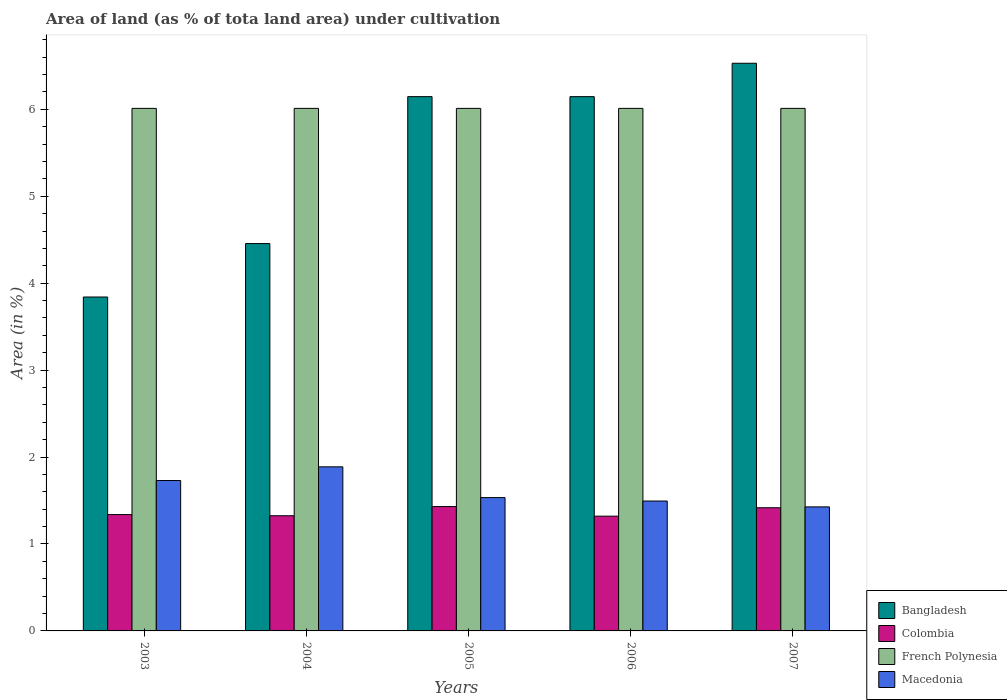How many different coloured bars are there?
Your answer should be compact. 4. How many groups of bars are there?
Offer a terse response. 5. Are the number of bars on each tick of the X-axis equal?
Make the answer very short. Yes. How many bars are there on the 1st tick from the left?
Make the answer very short. 4. How many bars are there on the 5th tick from the right?
Ensure brevity in your answer.  4. What is the label of the 1st group of bars from the left?
Make the answer very short. 2003. In how many cases, is the number of bars for a given year not equal to the number of legend labels?
Provide a succinct answer. 0. What is the percentage of land under cultivation in Bangladesh in 2005?
Your answer should be very brief. 6.15. Across all years, what is the maximum percentage of land under cultivation in Bangladesh?
Offer a terse response. 6.53. Across all years, what is the minimum percentage of land under cultivation in Colombia?
Keep it short and to the point. 1.32. What is the total percentage of land under cultivation in French Polynesia in the graph?
Provide a short and direct response. 30.05. What is the difference between the percentage of land under cultivation in Colombia in 2003 and the percentage of land under cultivation in Macedonia in 2005?
Offer a very short reply. -0.2. What is the average percentage of land under cultivation in Colombia per year?
Provide a succinct answer. 1.37. In the year 2005, what is the difference between the percentage of land under cultivation in French Polynesia and percentage of land under cultivation in Colombia?
Your answer should be compact. 4.58. What is the ratio of the percentage of land under cultivation in Bangladesh in 2005 to that in 2006?
Offer a very short reply. 1. What is the difference between the highest and the lowest percentage of land under cultivation in Bangladesh?
Offer a very short reply. 2.69. In how many years, is the percentage of land under cultivation in Macedonia greater than the average percentage of land under cultivation in Macedonia taken over all years?
Offer a very short reply. 2. What does the 4th bar from the left in 2006 represents?
Ensure brevity in your answer.  Macedonia. What does the 1st bar from the right in 2005 represents?
Provide a short and direct response. Macedonia. Is it the case that in every year, the sum of the percentage of land under cultivation in Bangladesh and percentage of land under cultivation in Colombia is greater than the percentage of land under cultivation in Macedonia?
Ensure brevity in your answer.  Yes. How many bars are there?
Ensure brevity in your answer.  20. How many years are there in the graph?
Your answer should be very brief. 5. Are the values on the major ticks of Y-axis written in scientific E-notation?
Ensure brevity in your answer.  No. Does the graph contain grids?
Provide a short and direct response. No. What is the title of the graph?
Offer a very short reply. Area of land (as % of tota land area) under cultivation. What is the label or title of the Y-axis?
Your answer should be very brief. Area (in %). What is the Area (in %) of Bangladesh in 2003?
Give a very brief answer. 3.84. What is the Area (in %) of Colombia in 2003?
Provide a short and direct response. 1.34. What is the Area (in %) in French Polynesia in 2003?
Keep it short and to the point. 6.01. What is the Area (in %) in Macedonia in 2003?
Give a very brief answer. 1.73. What is the Area (in %) of Bangladesh in 2004?
Your answer should be very brief. 4.46. What is the Area (in %) in Colombia in 2004?
Your answer should be compact. 1.32. What is the Area (in %) of French Polynesia in 2004?
Provide a short and direct response. 6.01. What is the Area (in %) in Macedonia in 2004?
Offer a terse response. 1.89. What is the Area (in %) in Bangladesh in 2005?
Give a very brief answer. 6.15. What is the Area (in %) of Colombia in 2005?
Your response must be concise. 1.43. What is the Area (in %) in French Polynesia in 2005?
Make the answer very short. 6.01. What is the Area (in %) of Macedonia in 2005?
Ensure brevity in your answer.  1.53. What is the Area (in %) in Bangladesh in 2006?
Your response must be concise. 6.15. What is the Area (in %) in Colombia in 2006?
Provide a succinct answer. 1.32. What is the Area (in %) of French Polynesia in 2006?
Provide a succinct answer. 6.01. What is the Area (in %) in Macedonia in 2006?
Your answer should be very brief. 1.49. What is the Area (in %) of Bangladesh in 2007?
Your answer should be compact. 6.53. What is the Area (in %) of Colombia in 2007?
Keep it short and to the point. 1.42. What is the Area (in %) in French Polynesia in 2007?
Offer a terse response. 6.01. What is the Area (in %) of Macedonia in 2007?
Your answer should be compact. 1.43. Across all years, what is the maximum Area (in %) in Bangladesh?
Offer a terse response. 6.53. Across all years, what is the maximum Area (in %) in Colombia?
Provide a short and direct response. 1.43. Across all years, what is the maximum Area (in %) in French Polynesia?
Offer a very short reply. 6.01. Across all years, what is the maximum Area (in %) of Macedonia?
Make the answer very short. 1.89. Across all years, what is the minimum Area (in %) of Bangladesh?
Offer a terse response. 3.84. Across all years, what is the minimum Area (in %) in Colombia?
Ensure brevity in your answer.  1.32. Across all years, what is the minimum Area (in %) of French Polynesia?
Your response must be concise. 6.01. Across all years, what is the minimum Area (in %) in Macedonia?
Offer a terse response. 1.43. What is the total Area (in %) in Bangladesh in the graph?
Give a very brief answer. 27.12. What is the total Area (in %) of Colombia in the graph?
Ensure brevity in your answer.  6.83. What is the total Area (in %) in French Polynesia in the graph?
Provide a short and direct response. 30.05. What is the total Area (in %) of Macedonia in the graph?
Provide a short and direct response. 8.07. What is the difference between the Area (in %) of Bangladesh in 2003 and that in 2004?
Provide a short and direct response. -0.61. What is the difference between the Area (in %) of Colombia in 2003 and that in 2004?
Make the answer very short. 0.01. What is the difference between the Area (in %) of Macedonia in 2003 and that in 2004?
Your response must be concise. -0.16. What is the difference between the Area (in %) of Bangladesh in 2003 and that in 2005?
Keep it short and to the point. -2.3. What is the difference between the Area (in %) of Colombia in 2003 and that in 2005?
Keep it short and to the point. -0.09. What is the difference between the Area (in %) in Macedonia in 2003 and that in 2005?
Give a very brief answer. 0.2. What is the difference between the Area (in %) of Bangladesh in 2003 and that in 2006?
Provide a succinct answer. -2.3. What is the difference between the Area (in %) of Colombia in 2003 and that in 2006?
Offer a very short reply. 0.02. What is the difference between the Area (in %) of French Polynesia in 2003 and that in 2006?
Provide a succinct answer. 0. What is the difference between the Area (in %) of Macedonia in 2003 and that in 2006?
Provide a short and direct response. 0.24. What is the difference between the Area (in %) in Bangladesh in 2003 and that in 2007?
Offer a very short reply. -2.69. What is the difference between the Area (in %) of Colombia in 2003 and that in 2007?
Make the answer very short. -0.08. What is the difference between the Area (in %) in Macedonia in 2003 and that in 2007?
Give a very brief answer. 0.3. What is the difference between the Area (in %) in Bangladesh in 2004 and that in 2005?
Give a very brief answer. -1.69. What is the difference between the Area (in %) of Colombia in 2004 and that in 2005?
Offer a very short reply. -0.11. What is the difference between the Area (in %) of Macedonia in 2004 and that in 2005?
Your response must be concise. 0.35. What is the difference between the Area (in %) in Bangladesh in 2004 and that in 2006?
Provide a short and direct response. -1.69. What is the difference between the Area (in %) of Colombia in 2004 and that in 2006?
Offer a very short reply. 0. What is the difference between the Area (in %) in Macedonia in 2004 and that in 2006?
Your answer should be compact. 0.39. What is the difference between the Area (in %) in Bangladesh in 2004 and that in 2007?
Your answer should be compact. -2.07. What is the difference between the Area (in %) of Colombia in 2004 and that in 2007?
Make the answer very short. -0.09. What is the difference between the Area (in %) in Macedonia in 2004 and that in 2007?
Offer a very short reply. 0.46. What is the difference between the Area (in %) in Colombia in 2005 and that in 2006?
Make the answer very short. 0.11. What is the difference between the Area (in %) in Macedonia in 2005 and that in 2006?
Offer a very short reply. 0.04. What is the difference between the Area (in %) of Bangladesh in 2005 and that in 2007?
Make the answer very short. -0.38. What is the difference between the Area (in %) of Colombia in 2005 and that in 2007?
Your answer should be compact. 0.01. What is the difference between the Area (in %) of French Polynesia in 2005 and that in 2007?
Offer a very short reply. 0. What is the difference between the Area (in %) of Macedonia in 2005 and that in 2007?
Provide a succinct answer. 0.11. What is the difference between the Area (in %) in Bangladesh in 2006 and that in 2007?
Provide a short and direct response. -0.38. What is the difference between the Area (in %) in Colombia in 2006 and that in 2007?
Offer a very short reply. -0.1. What is the difference between the Area (in %) of French Polynesia in 2006 and that in 2007?
Keep it short and to the point. 0. What is the difference between the Area (in %) of Macedonia in 2006 and that in 2007?
Your answer should be compact. 0.07. What is the difference between the Area (in %) in Bangladesh in 2003 and the Area (in %) in Colombia in 2004?
Offer a very short reply. 2.52. What is the difference between the Area (in %) in Bangladesh in 2003 and the Area (in %) in French Polynesia in 2004?
Ensure brevity in your answer.  -2.17. What is the difference between the Area (in %) of Bangladesh in 2003 and the Area (in %) of Macedonia in 2004?
Your answer should be very brief. 1.95. What is the difference between the Area (in %) in Colombia in 2003 and the Area (in %) in French Polynesia in 2004?
Offer a very short reply. -4.67. What is the difference between the Area (in %) of Colombia in 2003 and the Area (in %) of Macedonia in 2004?
Your response must be concise. -0.55. What is the difference between the Area (in %) of French Polynesia in 2003 and the Area (in %) of Macedonia in 2004?
Your answer should be compact. 4.12. What is the difference between the Area (in %) in Bangladesh in 2003 and the Area (in %) in Colombia in 2005?
Make the answer very short. 2.41. What is the difference between the Area (in %) in Bangladesh in 2003 and the Area (in %) in French Polynesia in 2005?
Provide a short and direct response. -2.17. What is the difference between the Area (in %) of Bangladesh in 2003 and the Area (in %) of Macedonia in 2005?
Give a very brief answer. 2.31. What is the difference between the Area (in %) of Colombia in 2003 and the Area (in %) of French Polynesia in 2005?
Provide a short and direct response. -4.67. What is the difference between the Area (in %) of Colombia in 2003 and the Area (in %) of Macedonia in 2005?
Offer a very short reply. -0.2. What is the difference between the Area (in %) of French Polynesia in 2003 and the Area (in %) of Macedonia in 2005?
Keep it short and to the point. 4.48. What is the difference between the Area (in %) in Bangladesh in 2003 and the Area (in %) in Colombia in 2006?
Offer a very short reply. 2.52. What is the difference between the Area (in %) in Bangladesh in 2003 and the Area (in %) in French Polynesia in 2006?
Make the answer very short. -2.17. What is the difference between the Area (in %) of Bangladesh in 2003 and the Area (in %) of Macedonia in 2006?
Ensure brevity in your answer.  2.35. What is the difference between the Area (in %) of Colombia in 2003 and the Area (in %) of French Polynesia in 2006?
Keep it short and to the point. -4.67. What is the difference between the Area (in %) in Colombia in 2003 and the Area (in %) in Macedonia in 2006?
Ensure brevity in your answer.  -0.16. What is the difference between the Area (in %) in French Polynesia in 2003 and the Area (in %) in Macedonia in 2006?
Ensure brevity in your answer.  4.52. What is the difference between the Area (in %) of Bangladesh in 2003 and the Area (in %) of Colombia in 2007?
Your answer should be very brief. 2.42. What is the difference between the Area (in %) of Bangladesh in 2003 and the Area (in %) of French Polynesia in 2007?
Give a very brief answer. -2.17. What is the difference between the Area (in %) of Bangladesh in 2003 and the Area (in %) of Macedonia in 2007?
Ensure brevity in your answer.  2.41. What is the difference between the Area (in %) in Colombia in 2003 and the Area (in %) in French Polynesia in 2007?
Your answer should be very brief. -4.67. What is the difference between the Area (in %) in Colombia in 2003 and the Area (in %) in Macedonia in 2007?
Offer a very short reply. -0.09. What is the difference between the Area (in %) of French Polynesia in 2003 and the Area (in %) of Macedonia in 2007?
Offer a very short reply. 4.58. What is the difference between the Area (in %) in Bangladesh in 2004 and the Area (in %) in Colombia in 2005?
Provide a succinct answer. 3.03. What is the difference between the Area (in %) in Bangladesh in 2004 and the Area (in %) in French Polynesia in 2005?
Provide a short and direct response. -1.56. What is the difference between the Area (in %) in Bangladesh in 2004 and the Area (in %) in Macedonia in 2005?
Ensure brevity in your answer.  2.92. What is the difference between the Area (in %) in Colombia in 2004 and the Area (in %) in French Polynesia in 2005?
Offer a terse response. -4.69. What is the difference between the Area (in %) in Colombia in 2004 and the Area (in %) in Macedonia in 2005?
Your answer should be very brief. -0.21. What is the difference between the Area (in %) of French Polynesia in 2004 and the Area (in %) of Macedonia in 2005?
Provide a short and direct response. 4.48. What is the difference between the Area (in %) in Bangladesh in 2004 and the Area (in %) in Colombia in 2006?
Your answer should be compact. 3.14. What is the difference between the Area (in %) of Bangladesh in 2004 and the Area (in %) of French Polynesia in 2006?
Provide a short and direct response. -1.56. What is the difference between the Area (in %) of Bangladesh in 2004 and the Area (in %) of Macedonia in 2006?
Keep it short and to the point. 2.96. What is the difference between the Area (in %) of Colombia in 2004 and the Area (in %) of French Polynesia in 2006?
Your answer should be compact. -4.69. What is the difference between the Area (in %) in Colombia in 2004 and the Area (in %) in Macedonia in 2006?
Your answer should be compact. -0.17. What is the difference between the Area (in %) in French Polynesia in 2004 and the Area (in %) in Macedonia in 2006?
Offer a very short reply. 4.52. What is the difference between the Area (in %) in Bangladesh in 2004 and the Area (in %) in Colombia in 2007?
Provide a succinct answer. 3.04. What is the difference between the Area (in %) of Bangladesh in 2004 and the Area (in %) of French Polynesia in 2007?
Provide a short and direct response. -1.56. What is the difference between the Area (in %) of Bangladesh in 2004 and the Area (in %) of Macedonia in 2007?
Your response must be concise. 3.03. What is the difference between the Area (in %) in Colombia in 2004 and the Area (in %) in French Polynesia in 2007?
Give a very brief answer. -4.69. What is the difference between the Area (in %) of Colombia in 2004 and the Area (in %) of Macedonia in 2007?
Provide a short and direct response. -0.1. What is the difference between the Area (in %) of French Polynesia in 2004 and the Area (in %) of Macedonia in 2007?
Provide a succinct answer. 4.58. What is the difference between the Area (in %) of Bangladesh in 2005 and the Area (in %) of Colombia in 2006?
Your answer should be compact. 4.83. What is the difference between the Area (in %) in Bangladesh in 2005 and the Area (in %) in French Polynesia in 2006?
Ensure brevity in your answer.  0.13. What is the difference between the Area (in %) in Bangladesh in 2005 and the Area (in %) in Macedonia in 2006?
Offer a terse response. 4.65. What is the difference between the Area (in %) of Colombia in 2005 and the Area (in %) of French Polynesia in 2006?
Ensure brevity in your answer.  -4.58. What is the difference between the Area (in %) in Colombia in 2005 and the Area (in %) in Macedonia in 2006?
Make the answer very short. -0.06. What is the difference between the Area (in %) of French Polynesia in 2005 and the Area (in %) of Macedonia in 2006?
Make the answer very short. 4.52. What is the difference between the Area (in %) of Bangladesh in 2005 and the Area (in %) of Colombia in 2007?
Your response must be concise. 4.73. What is the difference between the Area (in %) in Bangladesh in 2005 and the Area (in %) in French Polynesia in 2007?
Your answer should be compact. 0.13. What is the difference between the Area (in %) in Bangladesh in 2005 and the Area (in %) in Macedonia in 2007?
Your answer should be very brief. 4.72. What is the difference between the Area (in %) of Colombia in 2005 and the Area (in %) of French Polynesia in 2007?
Offer a very short reply. -4.58. What is the difference between the Area (in %) in Colombia in 2005 and the Area (in %) in Macedonia in 2007?
Offer a very short reply. 0. What is the difference between the Area (in %) in French Polynesia in 2005 and the Area (in %) in Macedonia in 2007?
Keep it short and to the point. 4.58. What is the difference between the Area (in %) in Bangladesh in 2006 and the Area (in %) in Colombia in 2007?
Your answer should be very brief. 4.73. What is the difference between the Area (in %) in Bangladesh in 2006 and the Area (in %) in French Polynesia in 2007?
Offer a very short reply. 0.13. What is the difference between the Area (in %) of Bangladesh in 2006 and the Area (in %) of Macedonia in 2007?
Give a very brief answer. 4.72. What is the difference between the Area (in %) of Colombia in 2006 and the Area (in %) of French Polynesia in 2007?
Keep it short and to the point. -4.69. What is the difference between the Area (in %) of Colombia in 2006 and the Area (in %) of Macedonia in 2007?
Ensure brevity in your answer.  -0.11. What is the difference between the Area (in %) of French Polynesia in 2006 and the Area (in %) of Macedonia in 2007?
Provide a succinct answer. 4.58. What is the average Area (in %) of Bangladesh per year?
Provide a short and direct response. 5.42. What is the average Area (in %) in Colombia per year?
Offer a very short reply. 1.37. What is the average Area (in %) in French Polynesia per year?
Your response must be concise. 6.01. What is the average Area (in %) of Macedonia per year?
Provide a succinct answer. 1.61. In the year 2003, what is the difference between the Area (in %) in Bangladesh and Area (in %) in Colombia?
Offer a very short reply. 2.5. In the year 2003, what is the difference between the Area (in %) of Bangladesh and Area (in %) of French Polynesia?
Provide a succinct answer. -2.17. In the year 2003, what is the difference between the Area (in %) in Bangladesh and Area (in %) in Macedonia?
Offer a terse response. 2.11. In the year 2003, what is the difference between the Area (in %) of Colombia and Area (in %) of French Polynesia?
Ensure brevity in your answer.  -4.67. In the year 2003, what is the difference between the Area (in %) of Colombia and Area (in %) of Macedonia?
Your answer should be compact. -0.39. In the year 2003, what is the difference between the Area (in %) in French Polynesia and Area (in %) in Macedonia?
Offer a terse response. 4.28. In the year 2004, what is the difference between the Area (in %) in Bangladesh and Area (in %) in Colombia?
Your answer should be compact. 3.13. In the year 2004, what is the difference between the Area (in %) in Bangladesh and Area (in %) in French Polynesia?
Your answer should be very brief. -1.56. In the year 2004, what is the difference between the Area (in %) in Bangladesh and Area (in %) in Macedonia?
Offer a terse response. 2.57. In the year 2004, what is the difference between the Area (in %) of Colombia and Area (in %) of French Polynesia?
Offer a very short reply. -4.69. In the year 2004, what is the difference between the Area (in %) of Colombia and Area (in %) of Macedonia?
Offer a very short reply. -0.56. In the year 2004, what is the difference between the Area (in %) in French Polynesia and Area (in %) in Macedonia?
Provide a succinct answer. 4.12. In the year 2005, what is the difference between the Area (in %) of Bangladesh and Area (in %) of Colombia?
Give a very brief answer. 4.72. In the year 2005, what is the difference between the Area (in %) of Bangladesh and Area (in %) of French Polynesia?
Your response must be concise. 0.13. In the year 2005, what is the difference between the Area (in %) of Bangladesh and Area (in %) of Macedonia?
Your answer should be compact. 4.61. In the year 2005, what is the difference between the Area (in %) in Colombia and Area (in %) in French Polynesia?
Give a very brief answer. -4.58. In the year 2005, what is the difference between the Area (in %) of Colombia and Area (in %) of Macedonia?
Ensure brevity in your answer.  -0.1. In the year 2005, what is the difference between the Area (in %) in French Polynesia and Area (in %) in Macedonia?
Ensure brevity in your answer.  4.48. In the year 2006, what is the difference between the Area (in %) in Bangladesh and Area (in %) in Colombia?
Provide a succinct answer. 4.83. In the year 2006, what is the difference between the Area (in %) in Bangladesh and Area (in %) in French Polynesia?
Ensure brevity in your answer.  0.13. In the year 2006, what is the difference between the Area (in %) of Bangladesh and Area (in %) of Macedonia?
Your response must be concise. 4.65. In the year 2006, what is the difference between the Area (in %) in Colombia and Area (in %) in French Polynesia?
Make the answer very short. -4.69. In the year 2006, what is the difference between the Area (in %) of Colombia and Area (in %) of Macedonia?
Your answer should be compact. -0.17. In the year 2006, what is the difference between the Area (in %) in French Polynesia and Area (in %) in Macedonia?
Your response must be concise. 4.52. In the year 2007, what is the difference between the Area (in %) of Bangladesh and Area (in %) of Colombia?
Provide a succinct answer. 5.11. In the year 2007, what is the difference between the Area (in %) of Bangladesh and Area (in %) of French Polynesia?
Your answer should be very brief. 0.52. In the year 2007, what is the difference between the Area (in %) in Bangladesh and Area (in %) in Macedonia?
Your response must be concise. 5.1. In the year 2007, what is the difference between the Area (in %) of Colombia and Area (in %) of French Polynesia?
Provide a succinct answer. -4.59. In the year 2007, what is the difference between the Area (in %) of Colombia and Area (in %) of Macedonia?
Give a very brief answer. -0.01. In the year 2007, what is the difference between the Area (in %) of French Polynesia and Area (in %) of Macedonia?
Your answer should be compact. 4.58. What is the ratio of the Area (in %) in Bangladesh in 2003 to that in 2004?
Offer a very short reply. 0.86. What is the ratio of the Area (in %) in Colombia in 2003 to that in 2004?
Keep it short and to the point. 1.01. What is the ratio of the Area (in %) in Macedonia in 2003 to that in 2004?
Provide a succinct answer. 0.92. What is the ratio of the Area (in %) in Bangladesh in 2003 to that in 2005?
Your answer should be very brief. 0.62. What is the ratio of the Area (in %) in Colombia in 2003 to that in 2005?
Your response must be concise. 0.94. What is the ratio of the Area (in %) in French Polynesia in 2003 to that in 2005?
Ensure brevity in your answer.  1. What is the ratio of the Area (in %) in Macedonia in 2003 to that in 2005?
Ensure brevity in your answer.  1.13. What is the ratio of the Area (in %) of Bangladesh in 2003 to that in 2006?
Offer a terse response. 0.62. What is the ratio of the Area (in %) in Colombia in 2003 to that in 2006?
Make the answer very short. 1.01. What is the ratio of the Area (in %) of French Polynesia in 2003 to that in 2006?
Your response must be concise. 1. What is the ratio of the Area (in %) of Macedonia in 2003 to that in 2006?
Ensure brevity in your answer.  1.16. What is the ratio of the Area (in %) of Bangladesh in 2003 to that in 2007?
Provide a succinct answer. 0.59. What is the ratio of the Area (in %) of Colombia in 2003 to that in 2007?
Offer a terse response. 0.94. What is the ratio of the Area (in %) in French Polynesia in 2003 to that in 2007?
Offer a terse response. 1. What is the ratio of the Area (in %) of Macedonia in 2003 to that in 2007?
Provide a short and direct response. 1.21. What is the ratio of the Area (in %) of Bangladesh in 2004 to that in 2005?
Offer a very short reply. 0.72. What is the ratio of the Area (in %) in Colombia in 2004 to that in 2005?
Offer a terse response. 0.93. What is the ratio of the Area (in %) in French Polynesia in 2004 to that in 2005?
Ensure brevity in your answer.  1. What is the ratio of the Area (in %) of Macedonia in 2004 to that in 2005?
Your response must be concise. 1.23. What is the ratio of the Area (in %) of Bangladesh in 2004 to that in 2006?
Provide a succinct answer. 0.72. What is the ratio of the Area (in %) in Macedonia in 2004 to that in 2006?
Offer a terse response. 1.26. What is the ratio of the Area (in %) of Bangladesh in 2004 to that in 2007?
Offer a very short reply. 0.68. What is the ratio of the Area (in %) of Colombia in 2004 to that in 2007?
Offer a very short reply. 0.94. What is the ratio of the Area (in %) of French Polynesia in 2004 to that in 2007?
Your response must be concise. 1. What is the ratio of the Area (in %) in Macedonia in 2004 to that in 2007?
Give a very brief answer. 1.32. What is the ratio of the Area (in %) of Bangladesh in 2005 to that in 2006?
Make the answer very short. 1. What is the ratio of the Area (in %) of Colombia in 2005 to that in 2006?
Your answer should be compact. 1.08. What is the ratio of the Area (in %) of French Polynesia in 2005 to that in 2006?
Your answer should be very brief. 1. What is the ratio of the Area (in %) of Macedonia in 2005 to that in 2006?
Offer a very short reply. 1.03. What is the ratio of the Area (in %) in Bangladesh in 2005 to that in 2007?
Provide a short and direct response. 0.94. What is the ratio of the Area (in %) of Colombia in 2005 to that in 2007?
Keep it short and to the point. 1.01. What is the ratio of the Area (in %) of Macedonia in 2005 to that in 2007?
Make the answer very short. 1.07. What is the ratio of the Area (in %) of Bangladesh in 2006 to that in 2007?
Give a very brief answer. 0.94. What is the ratio of the Area (in %) of Colombia in 2006 to that in 2007?
Your answer should be very brief. 0.93. What is the ratio of the Area (in %) of French Polynesia in 2006 to that in 2007?
Give a very brief answer. 1. What is the ratio of the Area (in %) in Macedonia in 2006 to that in 2007?
Provide a short and direct response. 1.05. What is the difference between the highest and the second highest Area (in %) of Bangladesh?
Give a very brief answer. 0.38. What is the difference between the highest and the second highest Area (in %) in Colombia?
Give a very brief answer. 0.01. What is the difference between the highest and the second highest Area (in %) of Macedonia?
Your answer should be compact. 0.16. What is the difference between the highest and the lowest Area (in %) in Bangladesh?
Your answer should be very brief. 2.69. What is the difference between the highest and the lowest Area (in %) of Colombia?
Give a very brief answer. 0.11. What is the difference between the highest and the lowest Area (in %) in Macedonia?
Provide a short and direct response. 0.46. 